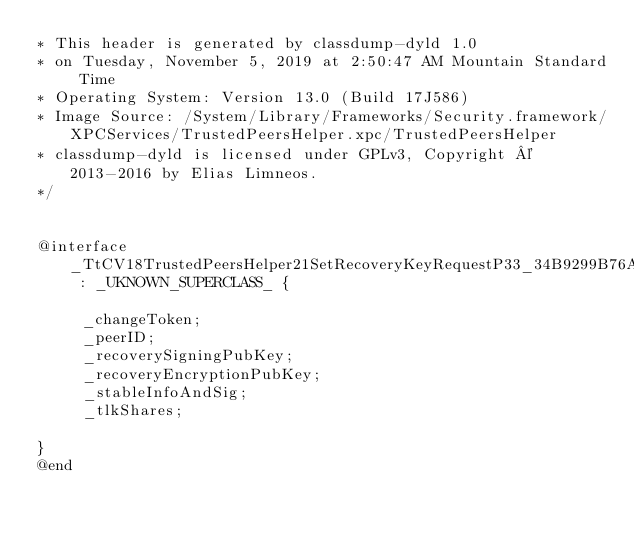<code> <loc_0><loc_0><loc_500><loc_500><_C_>* This header is generated by classdump-dyld 1.0
* on Tuesday, November 5, 2019 at 2:50:47 AM Mountain Standard Time
* Operating System: Version 13.0 (Build 17J586)
* Image Source: /System/Library/Frameworks/Security.framework/XPCServices/TrustedPeersHelper.xpc/TrustedPeersHelper
* classdump-dyld is licensed under GPLv3, Copyright © 2013-2016 by Elias Limneos.
*/


@interface _TtCV18TrustedPeersHelper21SetRecoveryKeyRequestP33_34B9299B76A248B7A76BCBE38D1FA2CF13_StorageClass : _UKNOWN_SUPERCLASS_ {

	 _changeToken;
	 _peerID;
	 _recoverySigningPubKey;
	 _recoveryEncryptionPubKey;
	 _stableInfoAndSig;
	 _tlkShares;

}
@end

</code> 